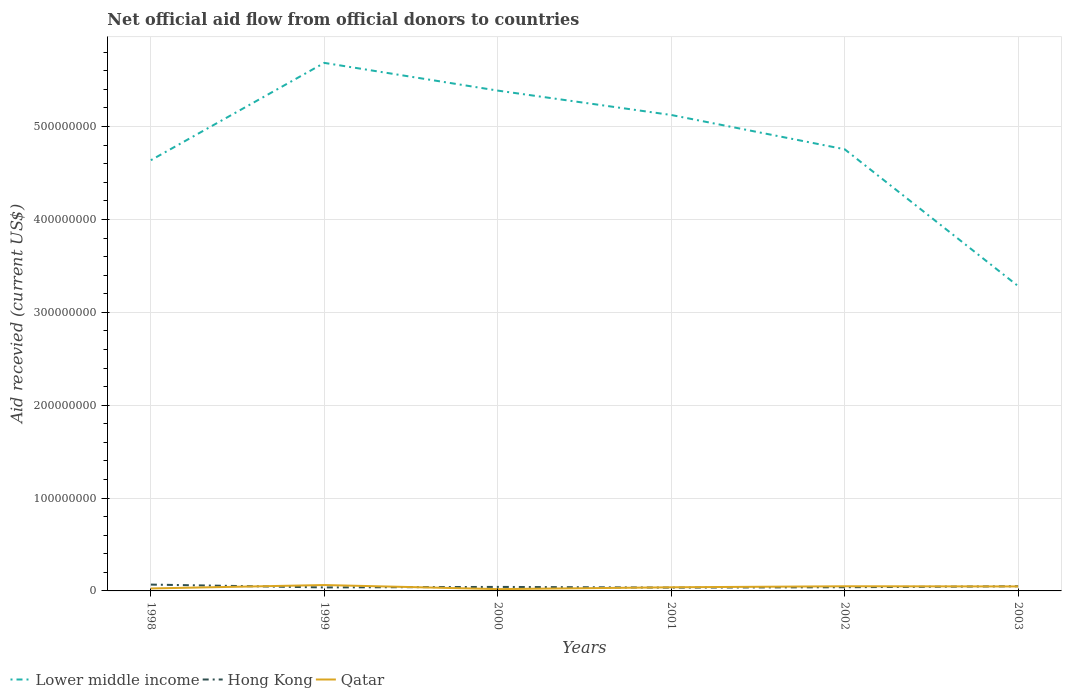How many different coloured lines are there?
Provide a short and direct response. 3. Does the line corresponding to Hong Kong intersect with the line corresponding to Qatar?
Keep it short and to the point. Yes. Is the number of lines equal to the number of legend labels?
Give a very brief answer. Yes. Across all years, what is the maximum total aid received in Qatar?
Give a very brief answer. 1.94e+06. In which year was the total aid received in Hong Kong maximum?
Provide a short and direct response. 2001. What is the total total aid received in Qatar in the graph?
Ensure brevity in your answer.  4.40e+06. What is the difference between the highest and the second highest total aid received in Lower middle income?
Give a very brief answer. 2.40e+08. How many lines are there?
Offer a terse response. 3. How many years are there in the graph?
Give a very brief answer. 6. What is the difference between two consecutive major ticks on the Y-axis?
Make the answer very short. 1.00e+08. Does the graph contain any zero values?
Provide a short and direct response. No. Does the graph contain grids?
Give a very brief answer. Yes. Where does the legend appear in the graph?
Offer a terse response. Bottom left. How are the legend labels stacked?
Your answer should be very brief. Horizontal. What is the title of the graph?
Offer a terse response. Net official aid flow from official donors to countries. What is the label or title of the X-axis?
Provide a succinct answer. Years. What is the label or title of the Y-axis?
Your answer should be compact. Aid recevied (current US$). What is the Aid recevied (current US$) of Lower middle income in 1998?
Ensure brevity in your answer.  4.64e+08. What is the Aid recevied (current US$) in Hong Kong in 1998?
Your answer should be very brief. 6.82e+06. What is the Aid recevied (current US$) in Qatar in 1998?
Keep it short and to the point. 2.66e+06. What is the Aid recevied (current US$) in Lower middle income in 1999?
Give a very brief answer. 5.69e+08. What is the Aid recevied (current US$) of Hong Kong in 1999?
Your response must be concise. 3.75e+06. What is the Aid recevied (current US$) in Qatar in 1999?
Keep it short and to the point. 6.34e+06. What is the Aid recevied (current US$) of Lower middle income in 2000?
Make the answer very short. 5.39e+08. What is the Aid recevied (current US$) of Hong Kong in 2000?
Provide a short and direct response. 4.33e+06. What is the Aid recevied (current US$) of Qatar in 2000?
Make the answer very short. 1.94e+06. What is the Aid recevied (current US$) of Lower middle income in 2001?
Provide a succinct answer. 5.12e+08. What is the Aid recevied (current US$) of Hong Kong in 2001?
Offer a very short reply. 3.57e+06. What is the Aid recevied (current US$) of Qatar in 2001?
Make the answer very short. 3.91e+06. What is the Aid recevied (current US$) in Lower middle income in 2002?
Your answer should be compact. 4.76e+08. What is the Aid recevied (current US$) in Hong Kong in 2002?
Give a very brief answer. 3.96e+06. What is the Aid recevied (current US$) of Qatar in 2002?
Keep it short and to the point. 5.02e+06. What is the Aid recevied (current US$) in Lower middle income in 2003?
Ensure brevity in your answer.  3.28e+08. What is the Aid recevied (current US$) in Hong Kong in 2003?
Offer a terse response. 5.02e+06. What is the Aid recevied (current US$) in Qatar in 2003?
Your answer should be compact. 4.82e+06. Across all years, what is the maximum Aid recevied (current US$) in Lower middle income?
Your response must be concise. 5.69e+08. Across all years, what is the maximum Aid recevied (current US$) of Hong Kong?
Give a very brief answer. 6.82e+06. Across all years, what is the maximum Aid recevied (current US$) of Qatar?
Offer a very short reply. 6.34e+06. Across all years, what is the minimum Aid recevied (current US$) in Lower middle income?
Make the answer very short. 3.28e+08. Across all years, what is the minimum Aid recevied (current US$) of Hong Kong?
Give a very brief answer. 3.57e+06. Across all years, what is the minimum Aid recevied (current US$) of Qatar?
Make the answer very short. 1.94e+06. What is the total Aid recevied (current US$) in Lower middle income in the graph?
Keep it short and to the point. 2.89e+09. What is the total Aid recevied (current US$) of Hong Kong in the graph?
Keep it short and to the point. 2.74e+07. What is the total Aid recevied (current US$) of Qatar in the graph?
Offer a terse response. 2.47e+07. What is the difference between the Aid recevied (current US$) in Lower middle income in 1998 and that in 1999?
Provide a succinct answer. -1.05e+08. What is the difference between the Aid recevied (current US$) of Hong Kong in 1998 and that in 1999?
Ensure brevity in your answer.  3.07e+06. What is the difference between the Aid recevied (current US$) of Qatar in 1998 and that in 1999?
Make the answer very short. -3.68e+06. What is the difference between the Aid recevied (current US$) of Lower middle income in 1998 and that in 2000?
Ensure brevity in your answer.  -7.50e+07. What is the difference between the Aid recevied (current US$) of Hong Kong in 1998 and that in 2000?
Offer a terse response. 2.49e+06. What is the difference between the Aid recevied (current US$) in Qatar in 1998 and that in 2000?
Provide a succinct answer. 7.20e+05. What is the difference between the Aid recevied (current US$) in Lower middle income in 1998 and that in 2001?
Provide a succinct answer. -4.87e+07. What is the difference between the Aid recevied (current US$) in Hong Kong in 1998 and that in 2001?
Give a very brief answer. 3.25e+06. What is the difference between the Aid recevied (current US$) in Qatar in 1998 and that in 2001?
Give a very brief answer. -1.25e+06. What is the difference between the Aid recevied (current US$) of Lower middle income in 1998 and that in 2002?
Make the answer very short. -1.18e+07. What is the difference between the Aid recevied (current US$) of Hong Kong in 1998 and that in 2002?
Your answer should be very brief. 2.86e+06. What is the difference between the Aid recevied (current US$) in Qatar in 1998 and that in 2002?
Ensure brevity in your answer.  -2.36e+06. What is the difference between the Aid recevied (current US$) in Lower middle income in 1998 and that in 2003?
Your response must be concise. 1.36e+08. What is the difference between the Aid recevied (current US$) in Hong Kong in 1998 and that in 2003?
Your response must be concise. 1.80e+06. What is the difference between the Aid recevied (current US$) of Qatar in 1998 and that in 2003?
Give a very brief answer. -2.16e+06. What is the difference between the Aid recevied (current US$) in Lower middle income in 1999 and that in 2000?
Your answer should be very brief. 2.98e+07. What is the difference between the Aid recevied (current US$) in Hong Kong in 1999 and that in 2000?
Give a very brief answer. -5.80e+05. What is the difference between the Aid recevied (current US$) of Qatar in 1999 and that in 2000?
Keep it short and to the point. 4.40e+06. What is the difference between the Aid recevied (current US$) in Lower middle income in 1999 and that in 2001?
Give a very brief answer. 5.61e+07. What is the difference between the Aid recevied (current US$) in Hong Kong in 1999 and that in 2001?
Your response must be concise. 1.80e+05. What is the difference between the Aid recevied (current US$) in Qatar in 1999 and that in 2001?
Offer a terse response. 2.43e+06. What is the difference between the Aid recevied (current US$) of Lower middle income in 1999 and that in 2002?
Ensure brevity in your answer.  9.30e+07. What is the difference between the Aid recevied (current US$) in Hong Kong in 1999 and that in 2002?
Ensure brevity in your answer.  -2.10e+05. What is the difference between the Aid recevied (current US$) in Qatar in 1999 and that in 2002?
Your answer should be compact. 1.32e+06. What is the difference between the Aid recevied (current US$) of Lower middle income in 1999 and that in 2003?
Your answer should be compact. 2.40e+08. What is the difference between the Aid recevied (current US$) of Hong Kong in 1999 and that in 2003?
Make the answer very short. -1.27e+06. What is the difference between the Aid recevied (current US$) of Qatar in 1999 and that in 2003?
Offer a terse response. 1.52e+06. What is the difference between the Aid recevied (current US$) in Lower middle income in 2000 and that in 2001?
Offer a terse response. 2.62e+07. What is the difference between the Aid recevied (current US$) in Hong Kong in 2000 and that in 2001?
Provide a succinct answer. 7.60e+05. What is the difference between the Aid recevied (current US$) in Qatar in 2000 and that in 2001?
Keep it short and to the point. -1.97e+06. What is the difference between the Aid recevied (current US$) of Lower middle income in 2000 and that in 2002?
Provide a succinct answer. 6.32e+07. What is the difference between the Aid recevied (current US$) of Qatar in 2000 and that in 2002?
Ensure brevity in your answer.  -3.08e+06. What is the difference between the Aid recevied (current US$) of Lower middle income in 2000 and that in 2003?
Make the answer very short. 2.10e+08. What is the difference between the Aid recevied (current US$) in Hong Kong in 2000 and that in 2003?
Offer a very short reply. -6.90e+05. What is the difference between the Aid recevied (current US$) in Qatar in 2000 and that in 2003?
Give a very brief answer. -2.88e+06. What is the difference between the Aid recevied (current US$) of Lower middle income in 2001 and that in 2002?
Your answer should be very brief. 3.69e+07. What is the difference between the Aid recevied (current US$) in Hong Kong in 2001 and that in 2002?
Your answer should be very brief. -3.90e+05. What is the difference between the Aid recevied (current US$) in Qatar in 2001 and that in 2002?
Ensure brevity in your answer.  -1.11e+06. What is the difference between the Aid recevied (current US$) in Lower middle income in 2001 and that in 2003?
Offer a terse response. 1.84e+08. What is the difference between the Aid recevied (current US$) in Hong Kong in 2001 and that in 2003?
Provide a succinct answer. -1.45e+06. What is the difference between the Aid recevied (current US$) of Qatar in 2001 and that in 2003?
Give a very brief answer. -9.10e+05. What is the difference between the Aid recevied (current US$) in Lower middle income in 2002 and that in 2003?
Offer a terse response. 1.47e+08. What is the difference between the Aid recevied (current US$) of Hong Kong in 2002 and that in 2003?
Provide a short and direct response. -1.06e+06. What is the difference between the Aid recevied (current US$) in Lower middle income in 1998 and the Aid recevied (current US$) in Hong Kong in 1999?
Keep it short and to the point. 4.60e+08. What is the difference between the Aid recevied (current US$) of Lower middle income in 1998 and the Aid recevied (current US$) of Qatar in 1999?
Your answer should be very brief. 4.57e+08. What is the difference between the Aid recevied (current US$) in Lower middle income in 1998 and the Aid recevied (current US$) in Hong Kong in 2000?
Provide a short and direct response. 4.59e+08. What is the difference between the Aid recevied (current US$) of Lower middle income in 1998 and the Aid recevied (current US$) of Qatar in 2000?
Ensure brevity in your answer.  4.62e+08. What is the difference between the Aid recevied (current US$) in Hong Kong in 1998 and the Aid recevied (current US$) in Qatar in 2000?
Offer a terse response. 4.88e+06. What is the difference between the Aid recevied (current US$) in Lower middle income in 1998 and the Aid recevied (current US$) in Hong Kong in 2001?
Give a very brief answer. 4.60e+08. What is the difference between the Aid recevied (current US$) of Lower middle income in 1998 and the Aid recevied (current US$) of Qatar in 2001?
Offer a very short reply. 4.60e+08. What is the difference between the Aid recevied (current US$) of Hong Kong in 1998 and the Aid recevied (current US$) of Qatar in 2001?
Offer a terse response. 2.91e+06. What is the difference between the Aid recevied (current US$) of Lower middle income in 1998 and the Aid recevied (current US$) of Hong Kong in 2002?
Your answer should be very brief. 4.60e+08. What is the difference between the Aid recevied (current US$) in Lower middle income in 1998 and the Aid recevied (current US$) in Qatar in 2002?
Offer a terse response. 4.59e+08. What is the difference between the Aid recevied (current US$) of Hong Kong in 1998 and the Aid recevied (current US$) of Qatar in 2002?
Offer a very short reply. 1.80e+06. What is the difference between the Aid recevied (current US$) of Lower middle income in 1998 and the Aid recevied (current US$) of Hong Kong in 2003?
Your answer should be very brief. 4.59e+08. What is the difference between the Aid recevied (current US$) of Lower middle income in 1998 and the Aid recevied (current US$) of Qatar in 2003?
Provide a succinct answer. 4.59e+08. What is the difference between the Aid recevied (current US$) of Hong Kong in 1998 and the Aid recevied (current US$) of Qatar in 2003?
Offer a terse response. 2.00e+06. What is the difference between the Aid recevied (current US$) of Lower middle income in 1999 and the Aid recevied (current US$) of Hong Kong in 2000?
Ensure brevity in your answer.  5.64e+08. What is the difference between the Aid recevied (current US$) in Lower middle income in 1999 and the Aid recevied (current US$) in Qatar in 2000?
Your answer should be very brief. 5.67e+08. What is the difference between the Aid recevied (current US$) in Hong Kong in 1999 and the Aid recevied (current US$) in Qatar in 2000?
Ensure brevity in your answer.  1.81e+06. What is the difference between the Aid recevied (current US$) of Lower middle income in 1999 and the Aid recevied (current US$) of Hong Kong in 2001?
Keep it short and to the point. 5.65e+08. What is the difference between the Aid recevied (current US$) of Lower middle income in 1999 and the Aid recevied (current US$) of Qatar in 2001?
Give a very brief answer. 5.65e+08. What is the difference between the Aid recevied (current US$) in Lower middle income in 1999 and the Aid recevied (current US$) in Hong Kong in 2002?
Provide a short and direct response. 5.65e+08. What is the difference between the Aid recevied (current US$) of Lower middle income in 1999 and the Aid recevied (current US$) of Qatar in 2002?
Provide a succinct answer. 5.64e+08. What is the difference between the Aid recevied (current US$) in Hong Kong in 1999 and the Aid recevied (current US$) in Qatar in 2002?
Offer a very short reply. -1.27e+06. What is the difference between the Aid recevied (current US$) of Lower middle income in 1999 and the Aid recevied (current US$) of Hong Kong in 2003?
Your answer should be compact. 5.64e+08. What is the difference between the Aid recevied (current US$) of Lower middle income in 1999 and the Aid recevied (current US$) of Qatar in 2003?
Your answer should be very brief. 5.64e+08. What is the difference between the Aid recevied (current US$) of Hong Kong in 1999 and the Aid recevied (current US$) of Qatar in 2003?
Offer a terse response. -1.07e+06. What is the difference between the Aid recevied (current US$) in Lower middle income in 2000 and the Aid recevied (current US$) in Hong Kong in 2001?
Give a very brief answer. 5.35e+08. What is the difference between the Aid recevied (current US$) of Lower middle income in 2000 and the Aid recevied (current US$) of Qatar in 2001?
Ensure brevity in your answer.  5.35e+08. What is the difference between the Aid recevied (current US$) in Lower middle income in 2000 and the Aid recevied (current US$) in Hong Kong in 2002?
Provide a succinct answer. 5.35e+08. What is the difference between the Aid recevied (current US$) of Lower middle income in 2000 and the Aid recevied (current US$) of Qatar in 2002?
Provide a short and direct response. 5.34e+08. What is the difference between the Aid recevied (current US$) in Hong Kong in 2000 and the Aid recevied (current US$) in Qatar in 2002?
Your response must be concise. -6.90e+05. What is the difference between the Aid recevied (current US$) of Lower middle income in 2000 and the Aid recevied (current US$) of Hong Kong in 2003?
Your answer should be compact. 5.34e+08. What is the difference between the Aid recevied (current US$) in Lower middle income in 2000 and the Aid recevied (current US$) in Qatar in 2003?
Offer a very short reply. 5.34e+08. What is the difference between the Aid recevied (current US$) of Hong Kong in 2000 and the Aid recevied (current US$) of Qatar in 2003?
Your response must be concise. -4.90e+05. What is the difference between the Aid recevied (current US$) of Lower middle income in 2001 and the Aid recevied (current US$) of Hong Kong in 2002?
Give a very brief answer. 5.09e+08. What is the difference between the Aid recevied (current US$) in Lower middle income in 2001 and the Aid recevied (current US$) in Qatar in 2002?
Ensure brevity in your answer.  5.07e+08. What is the difference between the Aid recevied (current US$) in Hong Kong in 2001 and the Aid recevied (current US$) in Qatar in 2002?
Provide a short and direct response. -1.45e+06. What is the difference between the Aid recevied (current US$) in Lower middle income in 2001 and the Aid recevied (current US$) in Hong Kong in 2003?
Your answer should be compact. 5.07e+08. What is the difference between the Aid recevied (current US$) of Lower middle income in 2001 and the Aid recevied (current US$) of Qatar in 2003?
Ensure brevity in your answer.  5.08e+08. What is the difference between the Aid recevied (current US$) in Hong Kong in 2001 and the Aid recevied (current US$) in Qatar in 2003?
Keep it short and to the point. -1.25e+06. What is the difference between the Aid recevied (current US$) in Lower middle income in 2002 and the Aid recevied (current US$) in Hong Kong in 2003?
Your answer should be compact. 4.71e+08. What is the difference between the Aid recevied (current US$) of Lower middle income in 2002 and the Aid recevied (current US$) of Qatar in 2003?
Ensure brevity in your answer.  4.71e+08. What is the difference between the Aid recevied (current US$) in Hong Kong in 2002 and the Aid recevied (current US$) in Qatar in 2003?
Give a very brief answer. -8.60e+05. What is the average Aid recevied (current US$) in Lower middle income per year?
Offer a very short reply. 4.81e+08. What is the average Aid recevied (current US$) in Hong Kong per year?
Provide a succinct answer. 4.58e+06. What is the average Aid recevied (current US$) in Qatar per year?
Provide a succinct answer. 4.12e+06. In the year 1998, what is the difference between the Aid recevied (current US$) of Lower middle income and Aid recevied (current US$) of Hong Kong?
Offer a terse response. 4.57e+08. In the year 1998, what is the difference between the Aid recevied (current US$) of Lower middle income and Aid recevied (current US$) of Qatar?
Your response must be concise. 4.61e+08. In the year 1998, what is the difference between the Aid recevied (current US$) in Hong Kong and Aid recevied (current US$) in Qatar?
Provide a succinct answer. 4.16e+06. In the year 1999, what is the difference between the Aid recevied (current US$) of Lower middle income and Aid recevied (current US$) of Hong Kong?
Your answer should be very brief. 5.65e+08. In the year 1999, what is the difference between the Aid recevied (current US$) of Lower middle income and Aid recevied (current US$) of Qatar?
Your response must be concise. 5.62e+08. In the year 1999, what is the difference between the Aid recevied (current US$) of Hong Kong and Aid recevied (current US$) of Qatar?
Give a very brief answer. -2.59e+06. In the year 2000, what is the difference between the Aid recevied (current US$) in Lower middle income and Aid recevied (current US$) in Hong Kong?
Provide a short and direct response. 5.34e+08. In the year 2000, what is the difference between the Aid recevied (current US$) of Lower middle income and Aid recevied (current US$) of Qatar?
Keep it short and to the point. 5.37e+08. In the year 2000, what is the difference between the Aid recevied (current US$) of Hong Kong and Aid recevied (current US$) of Qatar?
Provide a short and direct response. 2.39e+06. In the year 2001, what is the difference between the Aid recevied (current US$) of Lower middle income and Aid recevied (current US$) of Hong Kong?
Give a very brief answer. 5.09e+08. In the year 2001, what is the difference between the Aid recevied (current US$) in Lower middle income and Aid recevied (current US$) in Qatar?
Offer a terse response. 5.09e+08. In the year 2002, what is the difference between the Aid recevied (current US$) in Lower middle income and Aid recevied (current US$) in Hong Kong?
Give a very brief answer. 4.72e+08. In the year 2002, what is the difference between the Aid recevied (current US$) in Lower middle income and Aid recevied (current US$) in Qatar?
Your response must be concise. 4.71e+08. In the year 2002, what is the difference between the Aid recevied (current US$) in Hong Kong and Aid recevied (current US$) in Qatar?
Your answer should be compact. -1.06e+06. In the year 2003, what is the difference between the Aid recevied (current US$) in Lower middle income and Aid recevied (current US$) in Hong Kong?
Make the answer very short. 3.23e+08. In the year 2003, what is the difference between the Aid recevied (current US$) in Lower middle income and Aid recevied (current US$) in Qatar?
Provide a succinct answer. 3.23e+08. In the year 2003, what is the difference between the Aid recevied (current US$) in Hong Kong and Aid recevied (current US$) in Qatar?
Provide a succinct answer. 2.00e+05. What is the ratio of the Aid recevied (current US$) in Lower middle income in 1998 to that in 1999?
Offer a very short reply. 0.82. What is the ratio of the Aid recevied (current US$) in Hong Kong in 1998 to that in 1999?
Provide a short and direct response. 1.82. What is the ratio of the Aid recevied (current US$) of Qatar in 1998 to that in 1999?
Give a very brief answer. 0.42. What is the ratio of the Aid recevied (current US$) of Lower middle income in 1998 to that in 2000?
Your response must be concise. 0.86. What is the ratio of the Aid recevied (current US$) in Hong Kong in 1998 to that in 2000?
Keep it short and to the point. 1.58. What is the ratio of the Aid recevied (current US$) in Qatar in 1998 to that in 2000?
Give a very brief answer. 1.37. What is the ratio of the Aid recevied (current US$) in Lower middle income in 1998 to that in 2001?
Your response must be concise. 0.91. What is the ratio of the Aid recevied (current US$) of Hong Kong in 1998 to that in 2001?
Your answer should be very brief. 1.91. What is the ratio of the Aid recevied (current US$) in Qatar in 1998 to that in 2001?
Offer a terse response. 0.68. What is the ratio of the Aid recevied (current US$) in Lower middle income in 1998 to that in 2002?
Provide a succinct answer. 0.98. What is the ratio of the Aid recevied (current US$) of Hong Kong in 1998 to that in 2002?
Offer a terse response. 1.72. What is the ratio of the Aid recevied (current US$) of Qatar in 1998 to that in 2002?
Give a very brief answer. 0.53. What is the ratio of the Aid recevied (current US$) of Lower middle income in 1998 to that in 2003?
Offer a very short reply. 1.41. What is the ratio of the Aid recevied (current US$) of Hong Kong in 1998 to that in 2003?
Make the answer very short. 1.36. What is the ratio of the Aid recevied (current US$) of Qatar in 1998 to that in 2003?
Offer a terse response. 0.55. What is the ratio of the Aid recevied (current US$) of Lower middle income in 1999 to that in 2000?
Offer a very short reply. 1.06. What is the ratio of the Aid recevied (current US$) of Hong Kong in 1999 to that in 2000?
Make the answer very short. 0.87. What is the ratio of the Aid recevied (current US$) in Qatar in 1999 to that in 2000?
Your answer should be compact. 3.27. What is the ratio of the Aid recevied (current US$) of Lower middle income in 1999 to that in 2001?
Make the answer very short. 1.11. What is the ratio of the Aid recevied (current US$) in Hong Kong in 1999 to that in 2001?
Keep it short and to the point. 1.05. What is the ratio of the Aid recevied (current US$) in Qatar in 1999 to that in 2001?
Your answer should be compact. 1.62. What is the ratio of the Aid recevied (current US$) of Lower middle income in 1999 to that in 2002?
Provide a succinct answer. 1.2. What is the ratio of the Aid recevied (current US$) of Hong Kong in 1999 to that in 2002?
Provide a short and direct response. 0.95. What is the ratio of the Aid recevied (current US$) in Qatar in 1999 to that in 2002?
Provide a short and direct response. 1.26. What is the ratio of the Aid recevied (current US$) in Lower middle income in 1999 to that in 2003?
Your response must be concise. 1.73. What is the ratio of the Aid recevied (current US$) in Hong Kong in 1999 to that in 2003?
Your response must be concise. 0.75. What is the ratio of the Aid recevied (current US$) in Qatar in 1999 to that in 2003?
Provide a short and direct response. 1.32. What is the ratio of the Aid recevied (current US$) of Lower middle income in 2000 to that in 2001?
Make the answer very short. 1.05. What is the ratio of the Aid recevied (current US$) in Hong Kong in 2000 to that in 2001?
Your response must be concise. 1.21. What is the ratio of the Aid recevied (current US$) in Qatar in 2000 to that in 2001?
Your answer should be compact. 0.5. What is the ratio of the Aid recevied (current US$) in Lower middle income in 2000 to that in 2002?
Offer a very short reply. 1.13. What is the ratio of the Aid recevied (current US$) of Hong Kong in 2000 to that in 2002?
Offer a very short reply. 1.09. What is the ratio of the Aid recevied (current US$) in Qatar in 2000 to that in 2002?
Offer a very short reply. 0.39. What is the ratio of the Aid recevied (current US$) of Lower middle income in 2000 to that in 2003?
Offer a very short reply. 1.64. What is the ratio of the Aid recevied (current US$) in Hong Kong in 2000 to that in 2003?
Provide a succinct answer. 0.86. What is the ratio of the Aid recevied (current US$) in Qatar in 2000 to that in 2003?
Give a very brief answer. 0.4. What is the ratio of the Aid recevied (current US$) in Lower middle income in 2001 to that in 2002?
Offer a very short reply. 1.08. What is the ratio of the Aid recevied (current US$) in Hong Kong in 2001 to that in 2002?
Your response must be concise. 0.9. What is the ratio of the Aid recevied (current US$) of Qatar in 2001 to that in 2002?
Offer a very short reply. 0.78. What is the ratio of the Aid recevied (current US$) in Lower middle income in 2001 to that in 2003?
Provide a succinct answer. 1.56. What is the ratio of the Aid recevied (current US$) in Hong Kong in 2001 to that in 2003?
Offer a terse response. 0.71. What is the ratio of the Aid recevied (current US$) of Qatar in 2001 to that in 2003?
Make the answer very short. 0.81. What is the ratio of the Aid recevied (current US$) of Lower middle income in 2002 to that in 2003?
Provide a succinct answer. 1.45. What is the ratio of the Aid recevied (current US$) of Hong Kong in 2002 to that in 2003?
Your answer should be compact. 0.79. What is the ratio of the Aid recevied (current US$) of Qatar in 2002 to that in 2003?
Your answer should be very brief. 1.04. What is the difference between the highest and the second highest Aid recevied (current US$) in Lower middle income?
Provide a succinct answer. 2.98e+07. What is the difference between the highest and the second highest Aid recevied (current US$) in Hong Kong?
Your answer should be very brief. 1.80e+06. What is the difference between the highest and the second highest Aid recevied (current US$) in Qatar?
Provide a short and direct response. 1.32e+06. What is the difference between the highest and the lowest Aid recevied (current US$) of Lower middle income?
Provide a short and direct response. 2.40e+08. What is the difference between the highest and the lowest Aid recevied (current US$) in Hong Kong?
Your answer should be very brief. 3.25e+06. What is the difference between the highest and the lowest Aid recevied (current US$) in Qatar?
Ensure brevity in your answer.  4.40e+06. 